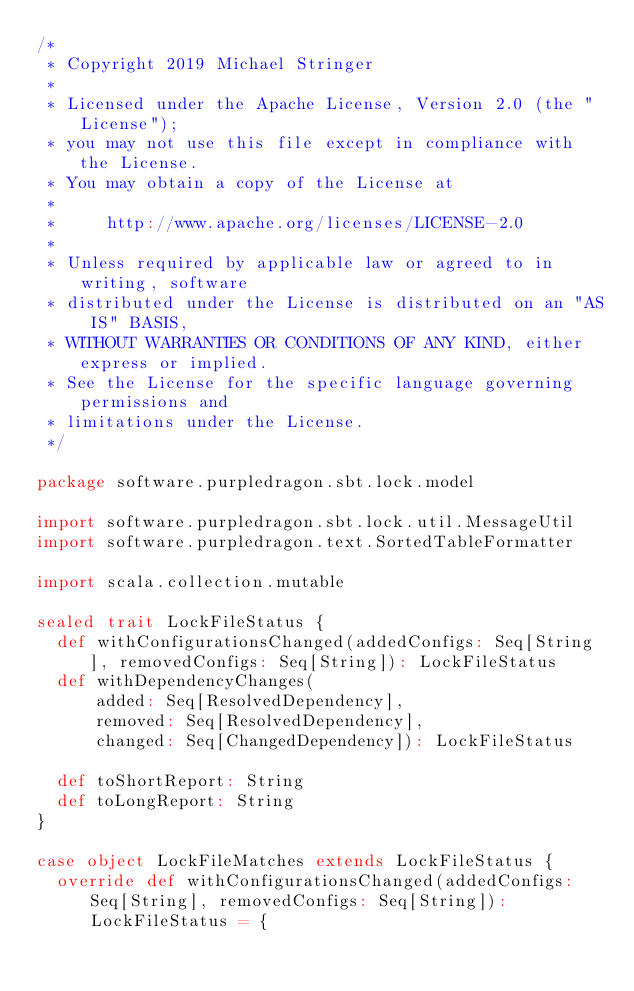<code> <loc_0><loc_0><loc_500><loc_500><_Scala_>/*
 * Copyright 2019 Michael Stringer
 *
 * Licensed under the Apache License, Version 2.0 (the "License");
 * you may not use this file except in compliance with the License.
 * You may obtain a copy of the License at
 *
 *     http://www.apache.org/licenses/LICENSE-2.0
 *
 * Unless required by applicable law or agreed to in writing, software
 * distributed under the License is distributed on an "AS IS" BASIS,
 * WITHOUT WARRANTIES OR CONDITIONS OF ANY KIND, either express or implied.
 * See the License for the specific language governing permissions and
 * limitations under the License.
 */

package software.purpledragon.sbt.lock.model

import software.purpledragon.sbt.lock.util.MessageUtil
import software.purpledragon.text.SortedTableFormatter

import scala.collection.mutable

sealed trait LockFileStatus {
  def withConfigurationsChanged(addedConfigs: Seq[String], removedConfigs: Seq[String]): LockFileStatus
  def withDependencyChanges(
      added: Seq[ResolvedDependency],
      removed: Seq[ResolvedDependency],
      changed: Seq[ChangedDependency]): LockFileStatus

  def toShortReport: String
  def toLongReport: String
}

case object LockFileMatches extends LockFileStatus {
  override def withConfigurationsChanged(addedConfigs: Seq[String], removedConfigs: Seq[String]): LockFileStatus = {</code> 